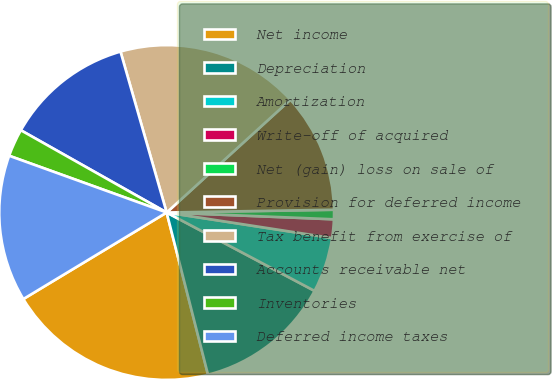Convert chart. <chart><loc_0><loc_0><loc_500><loc_500><pie_chart><fcel>Net income<fcel>Depreciation<fcel>Amortization<fcel>Write-off of acquired<fcel>Net (gain) loss on sale of<fcel>Provision for deferred income<fcel>Tax benefit from exercise of<fcel>Accounts receivable net<fcel>Inventories<fcel>Deferred income taxes<nl><fcel>20.33%<fcel>13.27%<fcel>5.32%<fcel>1.79%<fcel>0.91%<fcel>11.5%<fcel>17.68%<fcel>12.38%<fcel>2.67%<fcel>14.15%<nl></chart> 